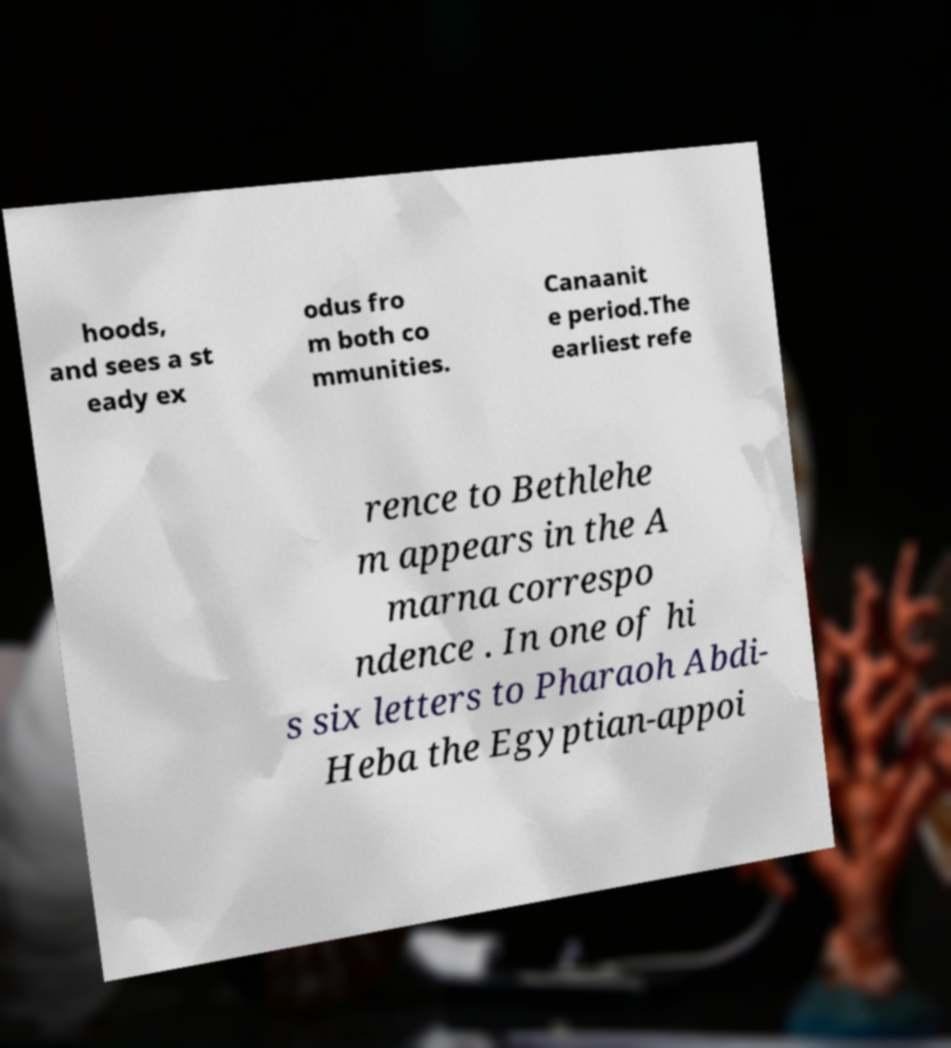Could you extract and type out the text from this image? hoods, and sees a st eady ex odus fro m both co mmunities. Canaanit e period.The earliest refe rence to Bethlehe m appears in the A marna correspo ndence . In one of hi s six letters to Pharaoh Abdi- Heba the Egyptian-appoi 